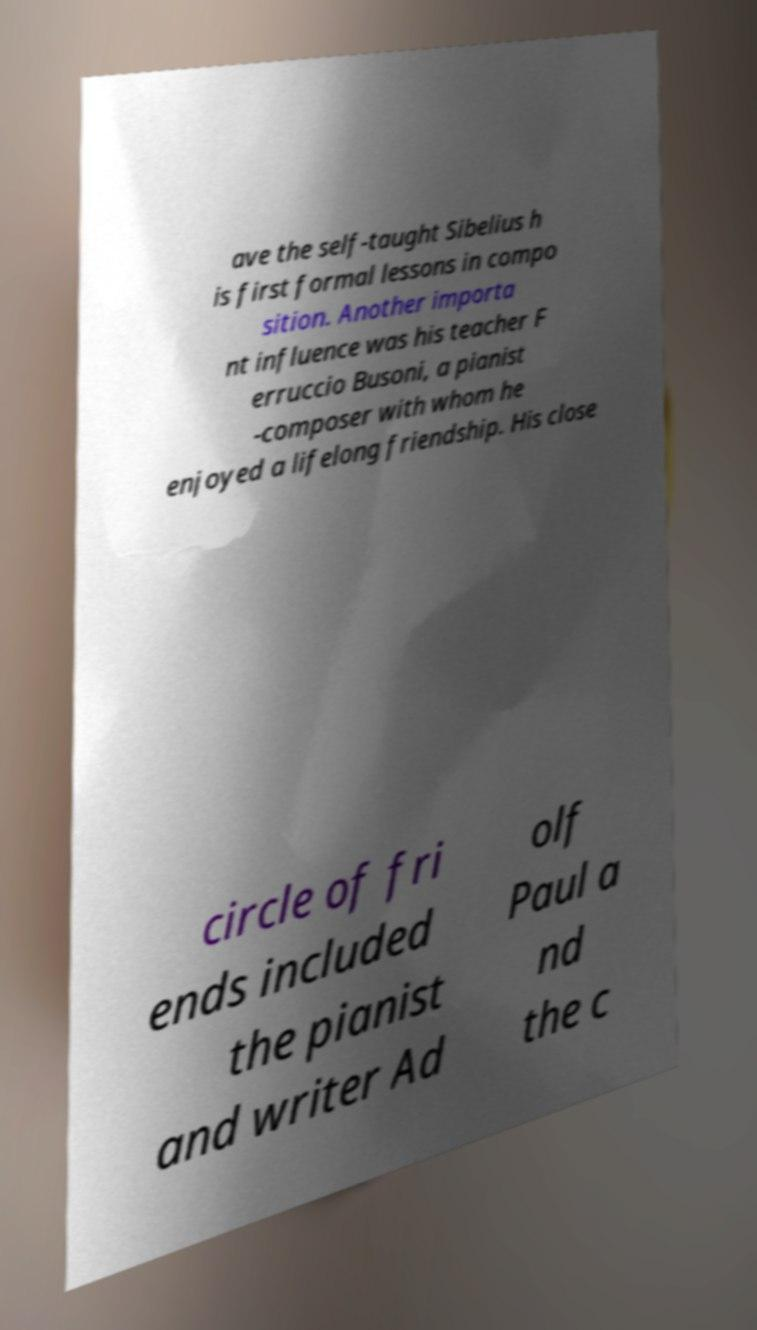There's text embedded in this image that I need extracted. Can you transcribe it verbatim? ave the self-taught Sibelius h is first formal lessons in compo sition. Another importa nt influence was his teacher F erruccio Busoni, a pianist -composer with whom he enjoyed a lifelong friendship. His close circle of fri ends included the pianist and writer Ad olf Paul a nd the c 